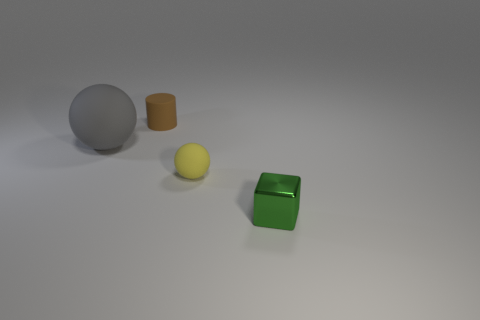Add 2 tiny matte balls. How many objects exist? 6 Subtract all blocks. How many objects are left? 3 Subtract all big matte spheres. Subtract all gray things. How many objects are left? 2 Add 2 tiny metallic blocks. How many tiny metallic blocks are left? 3 Add 4 yellow objects. How many yellow objects exist? 5 Subtract 1 yellow balls. How many objects are left? 3 